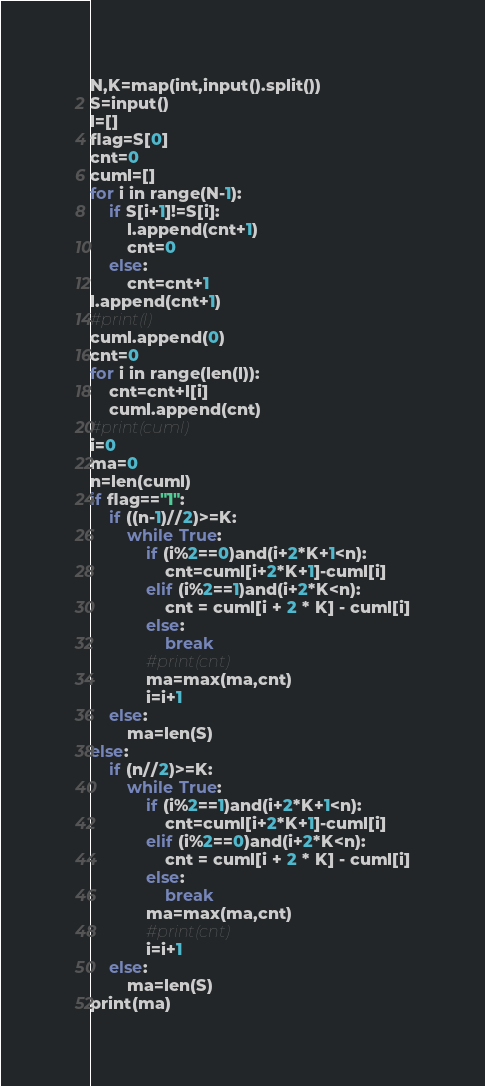<code> <loc_0><loc_0><loc_500><loc_500><_Python_>N,K=map(int,input().split())
S=input()
l=[]
flag=S[0]
cnt=0
cuml=[]
for i in range(N-1):
    if S[i+1]!=S[i]:
        l.append(cnt+1)
        cnt=0
    else:
        cnt=cnt+1
l.append(cnt+1)
#print(l)
cuml.append(0)
cnt=0
for i in range(len(l)):
    cnt=cnt+l[i]
    cuml.append(cnt)
#print(cuml)
i=0
ma=0
n=len(cuml)
if flag=="1":
    if ((n-1)//2)>=K:
        while True:
            if (i%2==0)and(i+2*K+1<n):
                cnt=cuml[i+2*K+1]-cuml[i]
            elif (i%2==1)and(i+2*K<n):
                cnt = cuml[i + 2 * K] - cuml[i]
            else:
                break
            #print(cnt)
            ma=max(ma,cnt)
            i=i+1
    else:
        ma=len(S)
else:
    if (n//2)>=K:
        while True:
            if (i%2==1)and(i+2*K+1<n):
                cnt=cuml[i+2*K+1]-cuml[i]
            elif (i%2==0)and(i+2*K<n):
                cnt = cuml[i + 2 * K] - cuml[i]
            else:
                break
            ma=max(ma,cnt)
            #print(cnt)
            i=i+1
    else:
        ma=len(S)
print(ma)

</code> 